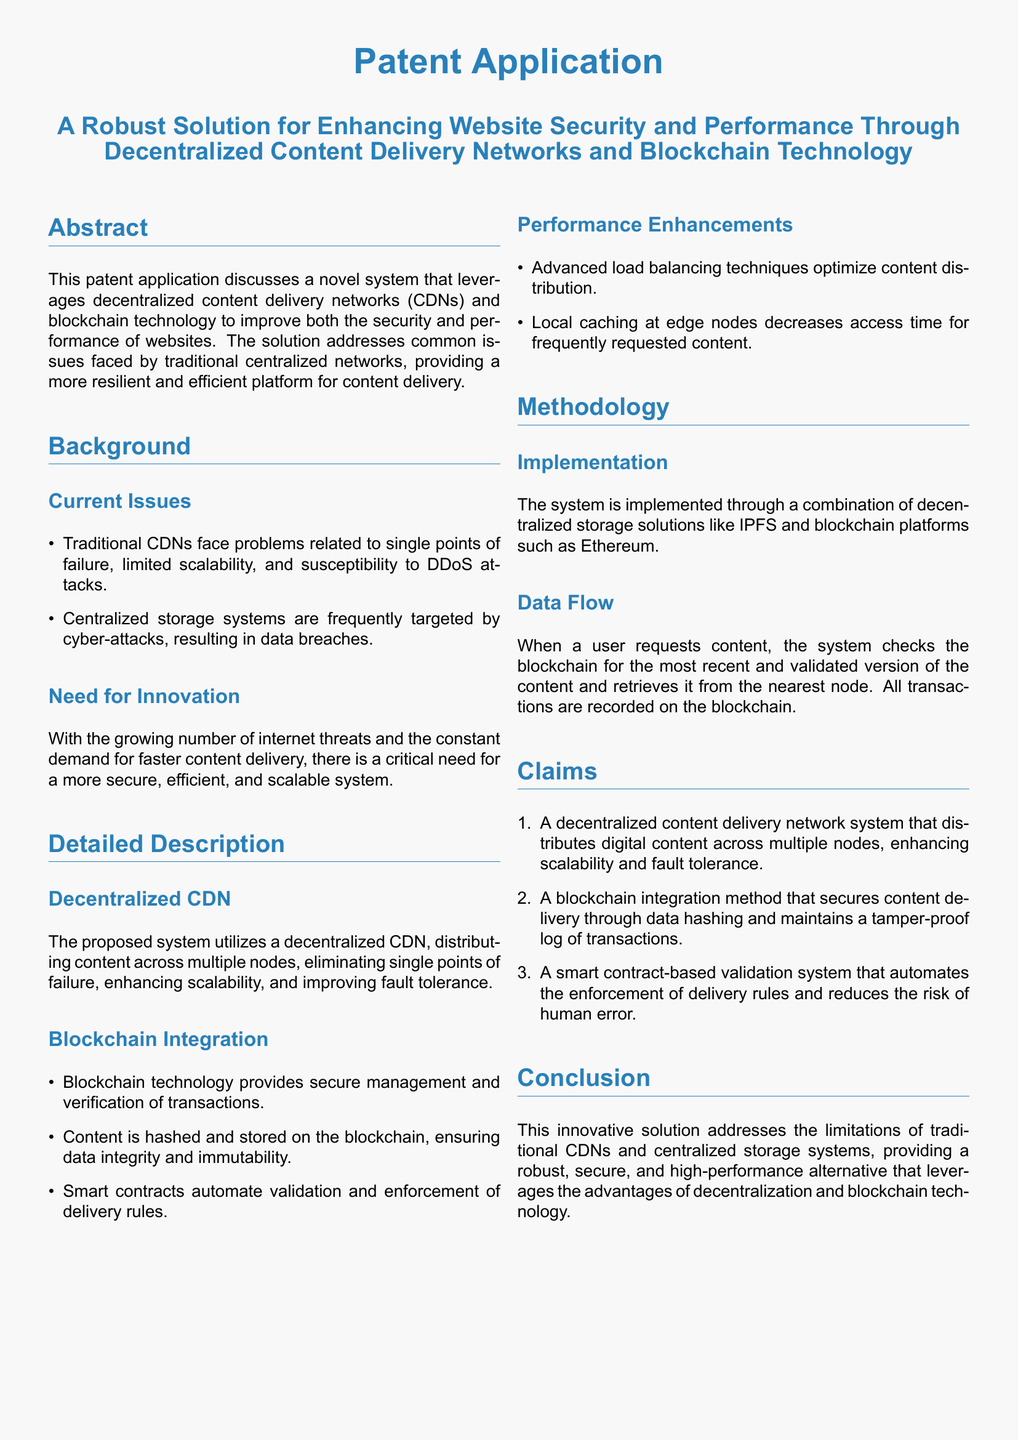What is the title of the patent application? The title of the patent application is provided in the document's header.
Answer: A Robust Solution for Enhancing Website Security and Performance Through Decentralized Content Delivery Networks and Blockchain Technology What technology is proposed for enhancing website security? The document discusses specific technologies aimed at improving security for websites.
Answer: Blockchain technology What is the main problem faced by traditional CDNs? The document lists several issues encountered by traditional CDNs.
Answer: Single points of failure What does the proposed system utilize for decentralized content delivery? The system’s primary method for content delivery is clearly stated in the detailed description.
Answer: Decentralized CDN Which blockchain platform is mentioned for implementation? The methodology section specifies particular blockchain platforms suitable for the innovative system.
Answer: Ethereum What enhancement technique is used to optimize content distribution? The document describes specific performance enhancements and techniques utilized in the proposed solution.
Answer: Advanced load balancing techniques What type of contracts automate validation in the system? The integration methods include types of contracts that facilitate automation within the document.
Answer: Smart contracts How does local caching affect access time? One of the performance enhancements addresses the benefits of local caching in the proposed system.
Answer: Decreases access time What is the primary purpose of hashing content in the proposed solution? The document explains the role of hashing in ensuring the integrity of the content delivery system.
Answer: Data integrity and immutability 